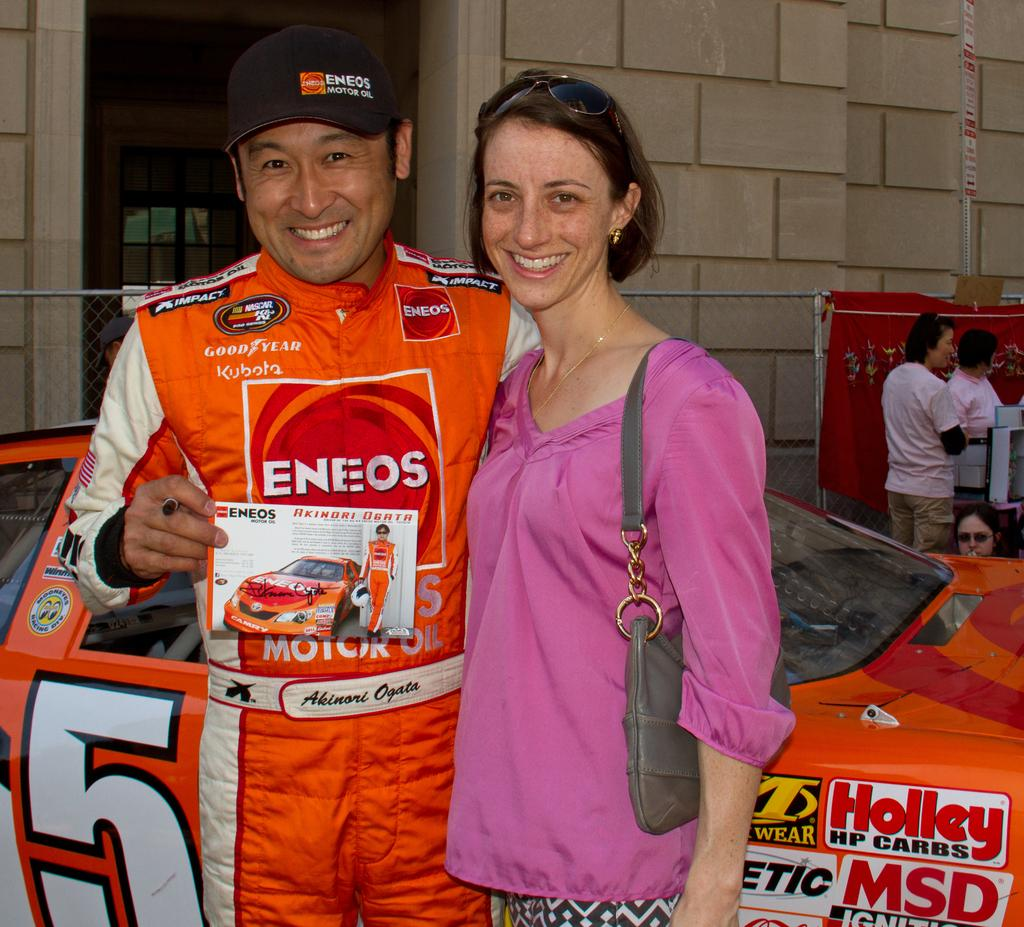<image>
Write a terse but informative summary of the picture. Eneos is the company sponsoring the race car driver. 